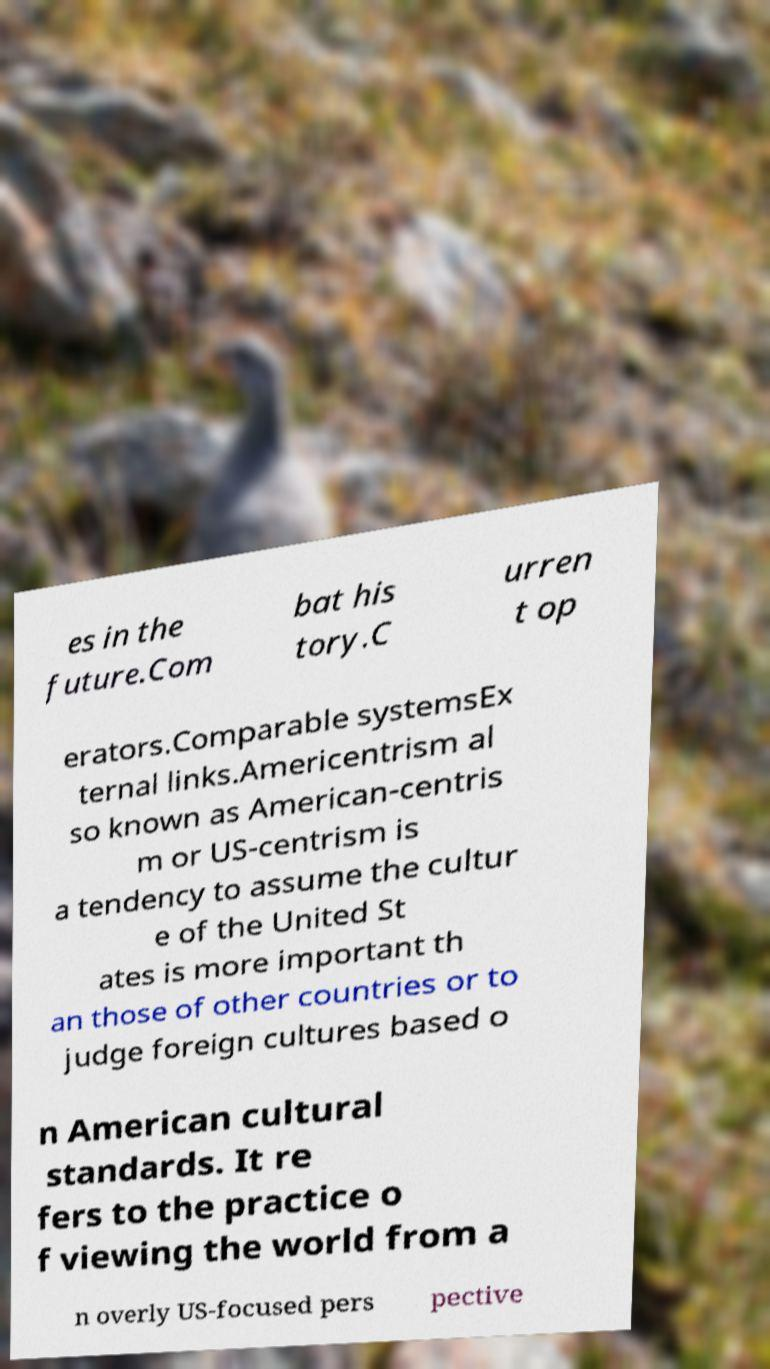For documentation purposes, I need the text within this image transcribed. Could you provide that? es in the future.Com bat his tory.C urren t op erators.Comparable systemsEx ternal links.Americentrism al so known as American-centris m or US-centrism is a tendency to assume the cultur e of the United St ates is more important th an those of other countries or to judge foreign cultures based o n American cultural standards. It re fers to the practice o f viewing the world from a n overly US-focused pers pective 